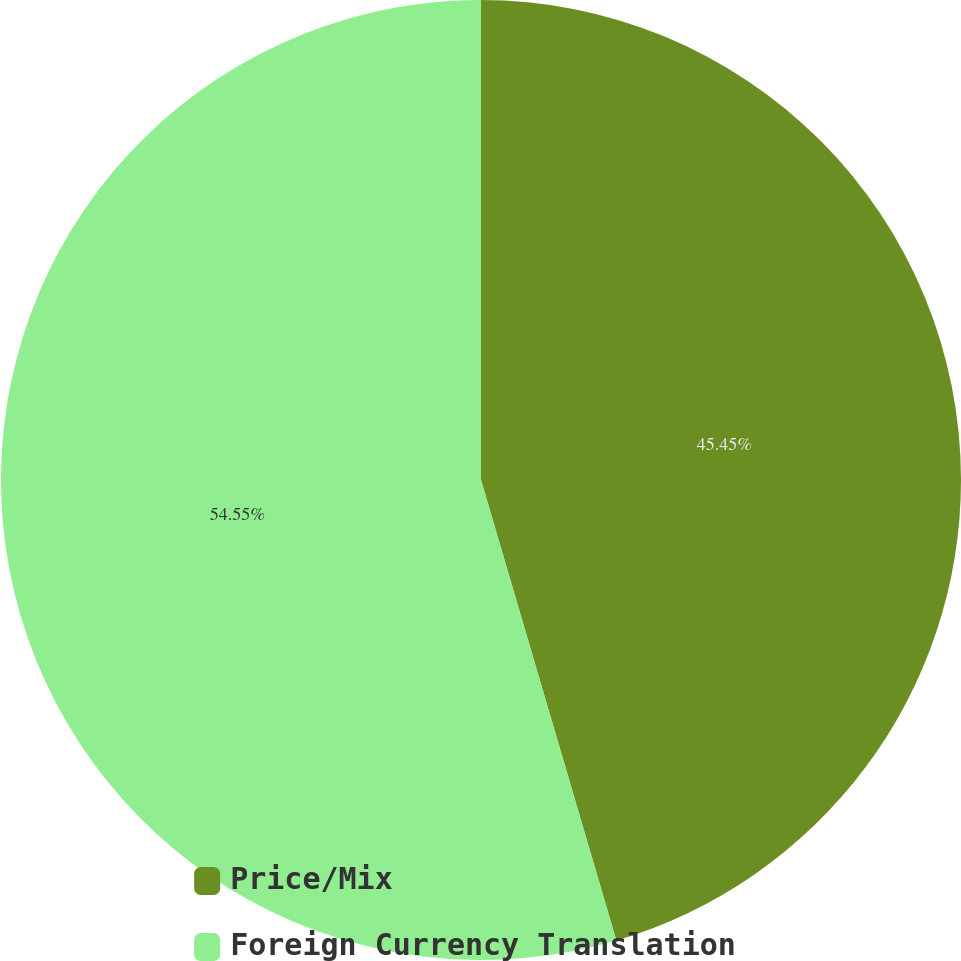<chart> <loc_0><loc_0><loc_500><loc_500><pie_chart><fcel>Price/Mix<fcel>Foreign Currency Translation<nl><fcel>45.45%<fcel>54.55%<nl></chart> 